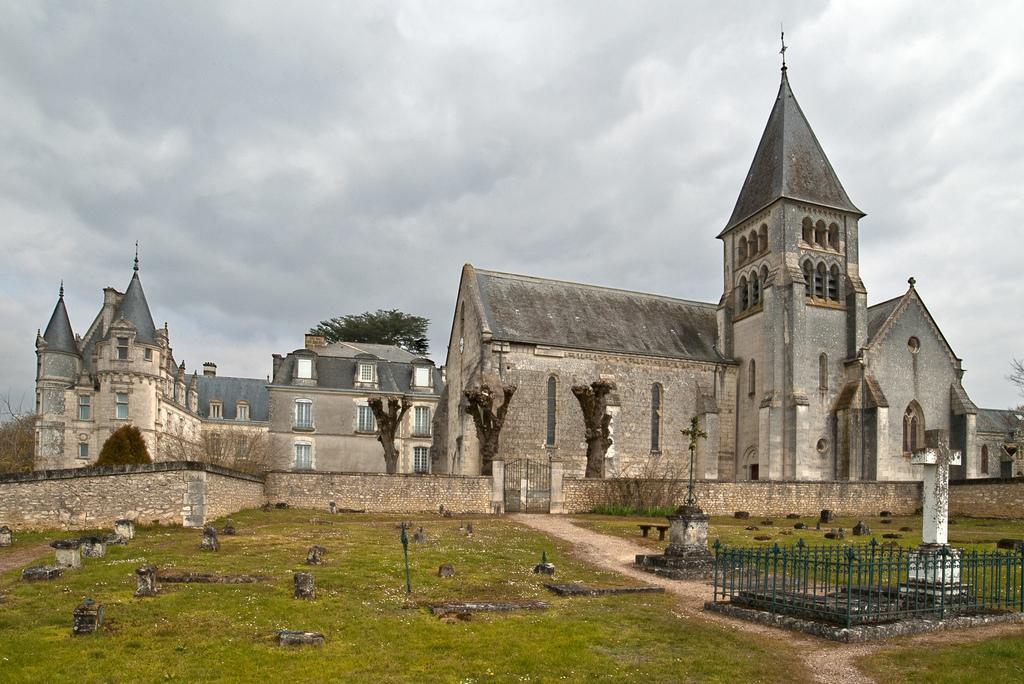Could you give a brief overview of what you see in this image? In this picture we can see building, cemeteries and around we can see some trees. 